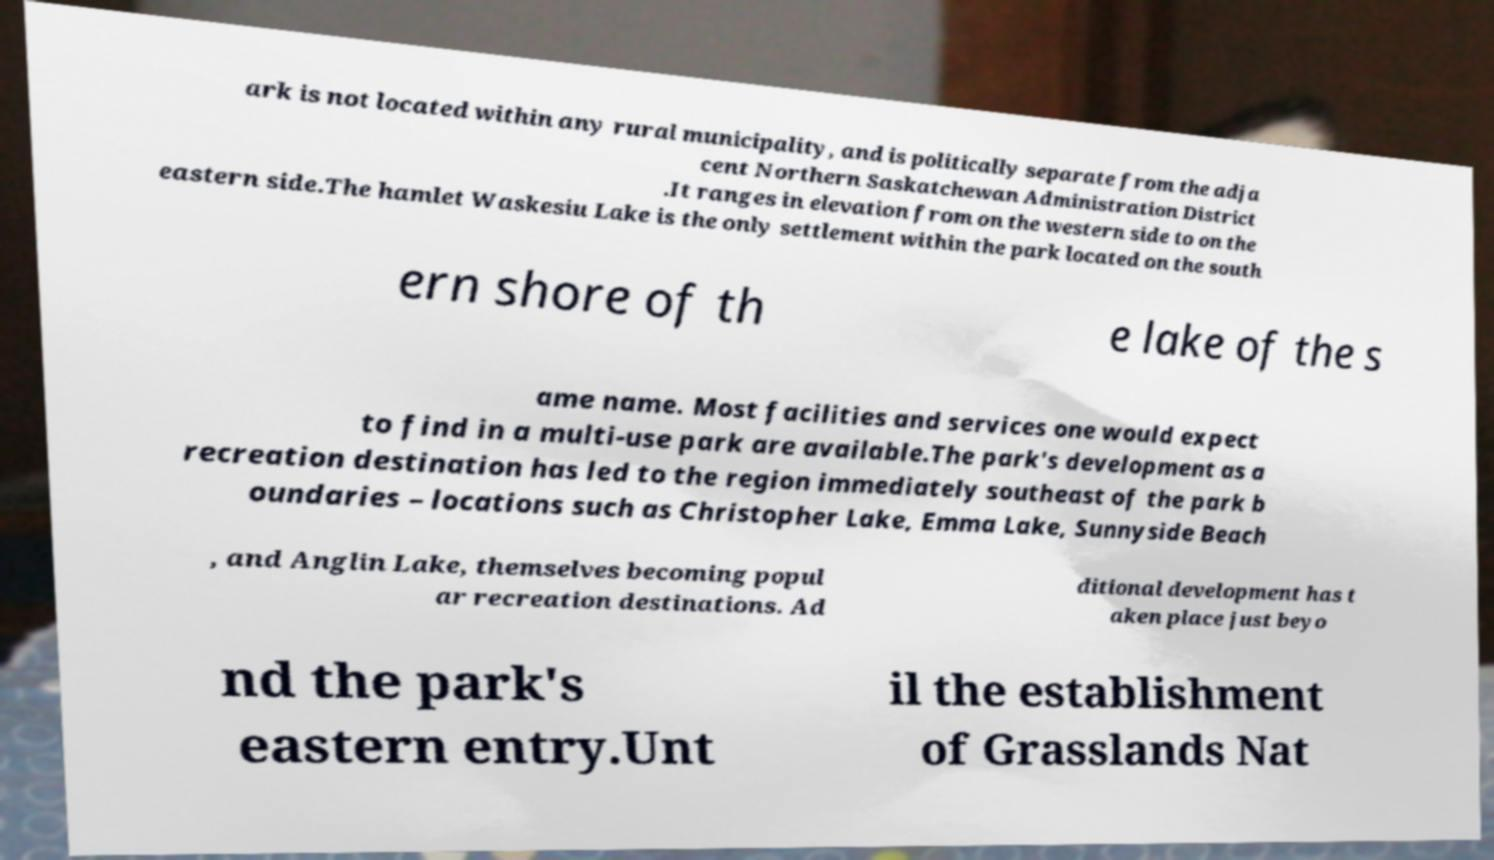What messages or text are displayed in this image? I need them in a readable, typed format. ark is not located within any rural municipality, and is politically separate from the adja cent Northern Saskatchewan Administration District .It ranges in elevation from on the western side to on the eastern side.The hamlet Waskesiu Lake is the only settlement within the park located on the south ern shore of th e lake of the s ame name. Most facilities and services one would expect to find in a multi-use park are available.The park's development as a recreation destination has led to the region immediately southeast of the park b oundaries – locations such as Christopher Lake, Emma Lake, Sunnyside Beach , and Anglin Lake, themselves becoming popul ar recreation destinations. Ad ditional development has t aken place just beyo nd the park's eastern entry.Unt il the establishment of Grasslands Nat 